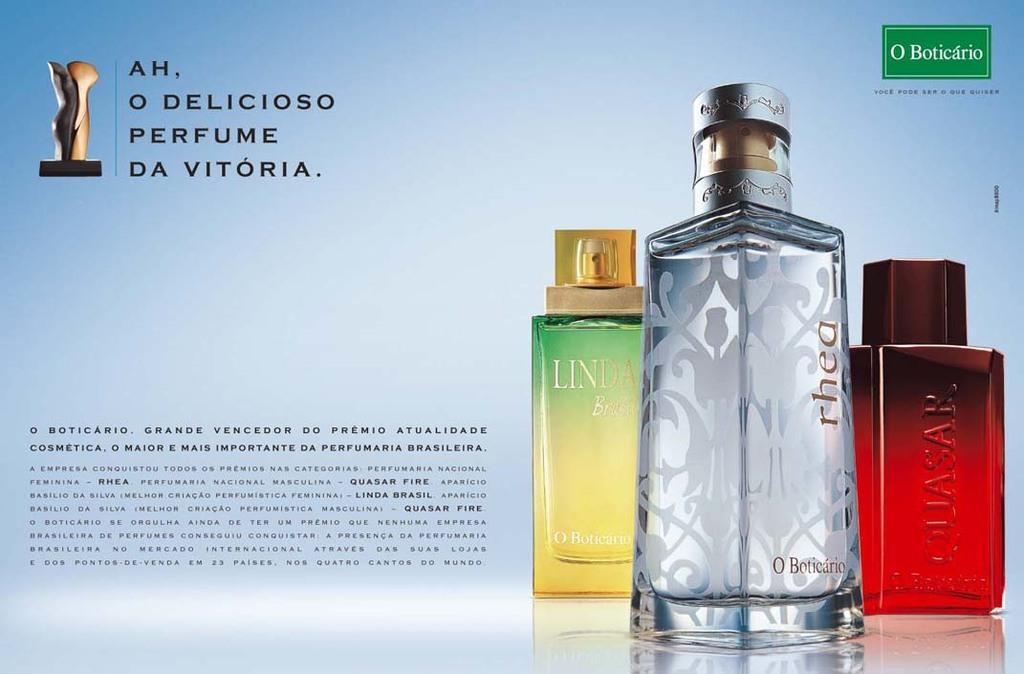<image>
Summarize the visual content of the image. A perfume ad has bottles and a green logo that says O Boticario. 